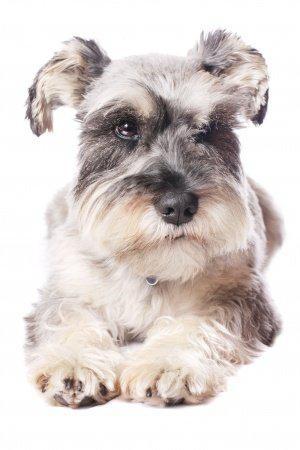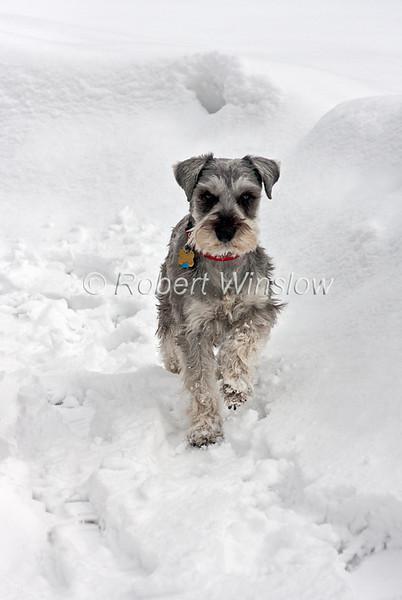The first image is the image on the left, the second image is the image on the right. Examine the images to the left and right. Is the description "The right image shows a schnauzer standing in the snow." accurate? Answer yes or no. Yes. 